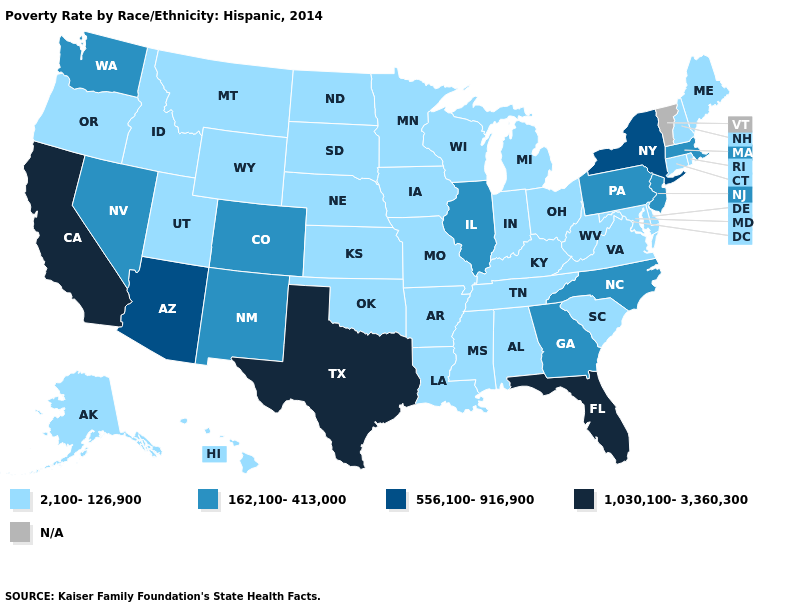Name the states that have a value in the range 1,030,100-3,360,300?
Answer briefly. California, Florida, Texas. What is the value of Colorado?
Quick response, please. 162,100-413,000. What is the lowest value in the Northeast?
Concise answer only. 2,100-126,900. What is the value of Utah?
Quick response, please. 2,100-126,900. Name the states that have a value in the range N/A?
Quick response, please. Vermont. Which states have the highest value in the USA?
Give a very brief answer. California, Florida, Texas. What is the value of North Dakota?
Keep it brief. 2,100-126,900. Does Florida have the highest value in the South?
Short answer required. Yes. What is the value of Missouri?
Answer briefly. 2,100-126,900. Is the legend a continuous bar?
Give a very brief answer. No. What is the value of Oregon?
Give a very brief answer. 2,100-126,900. Does Iowa have the lowest value in the MidWest?
Keep it brief. Yes. What is the value of Colorado?
Quick response, please. 162,100-413,000. Is the legend a continuous bar?
Write a very short answer. No. 